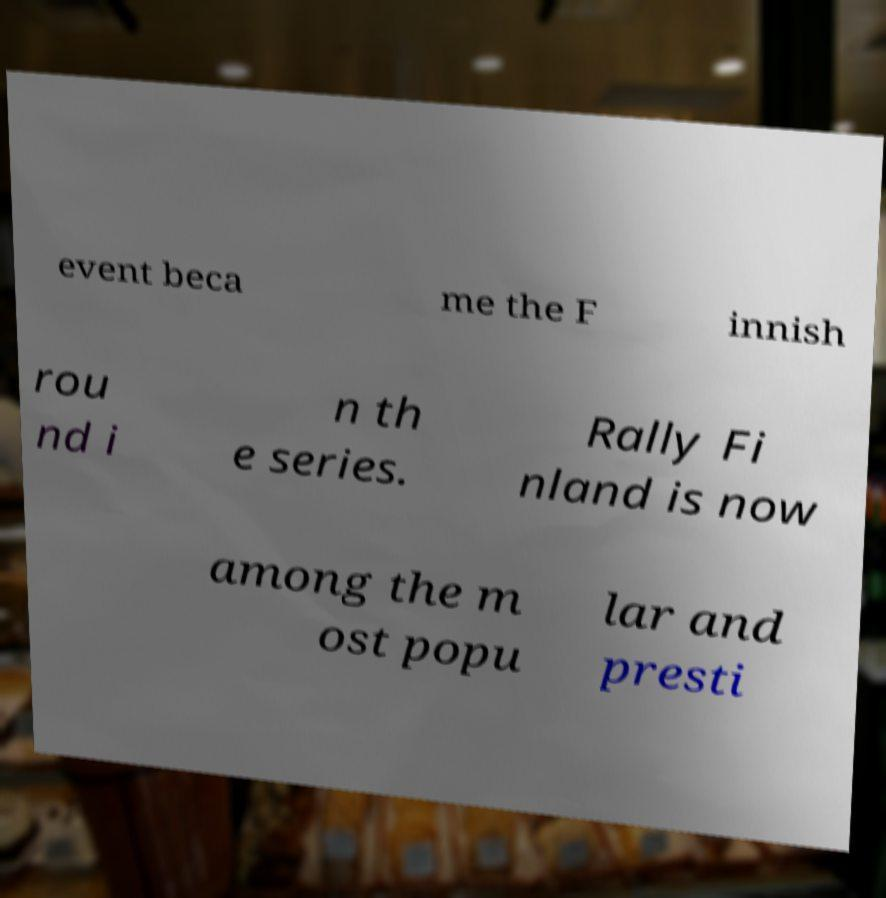I need the written content from this picture converted into text. Can you do that? event beca me the F innish rou nd i n th e series. Rally Fi nland is now among the m ost popu lar and presti 